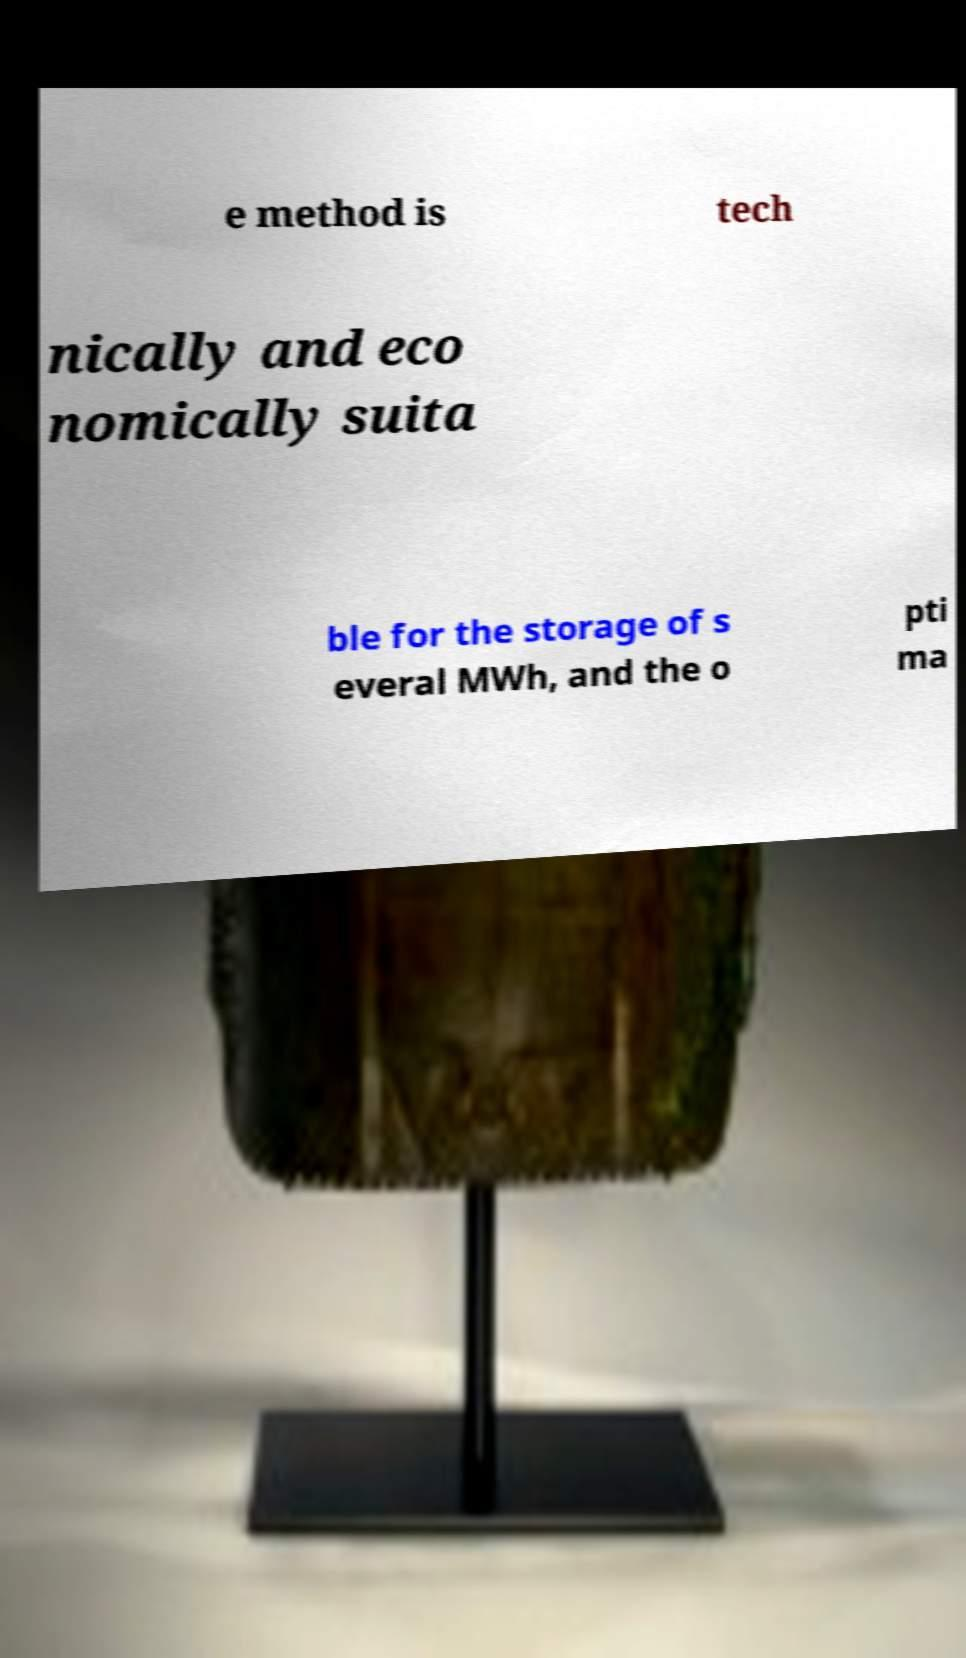Please read and relay the text visible in this image. What does it say? e method is tech nically and eco nomically suita ble for the storage of s everal MWh, and the o pti ma 